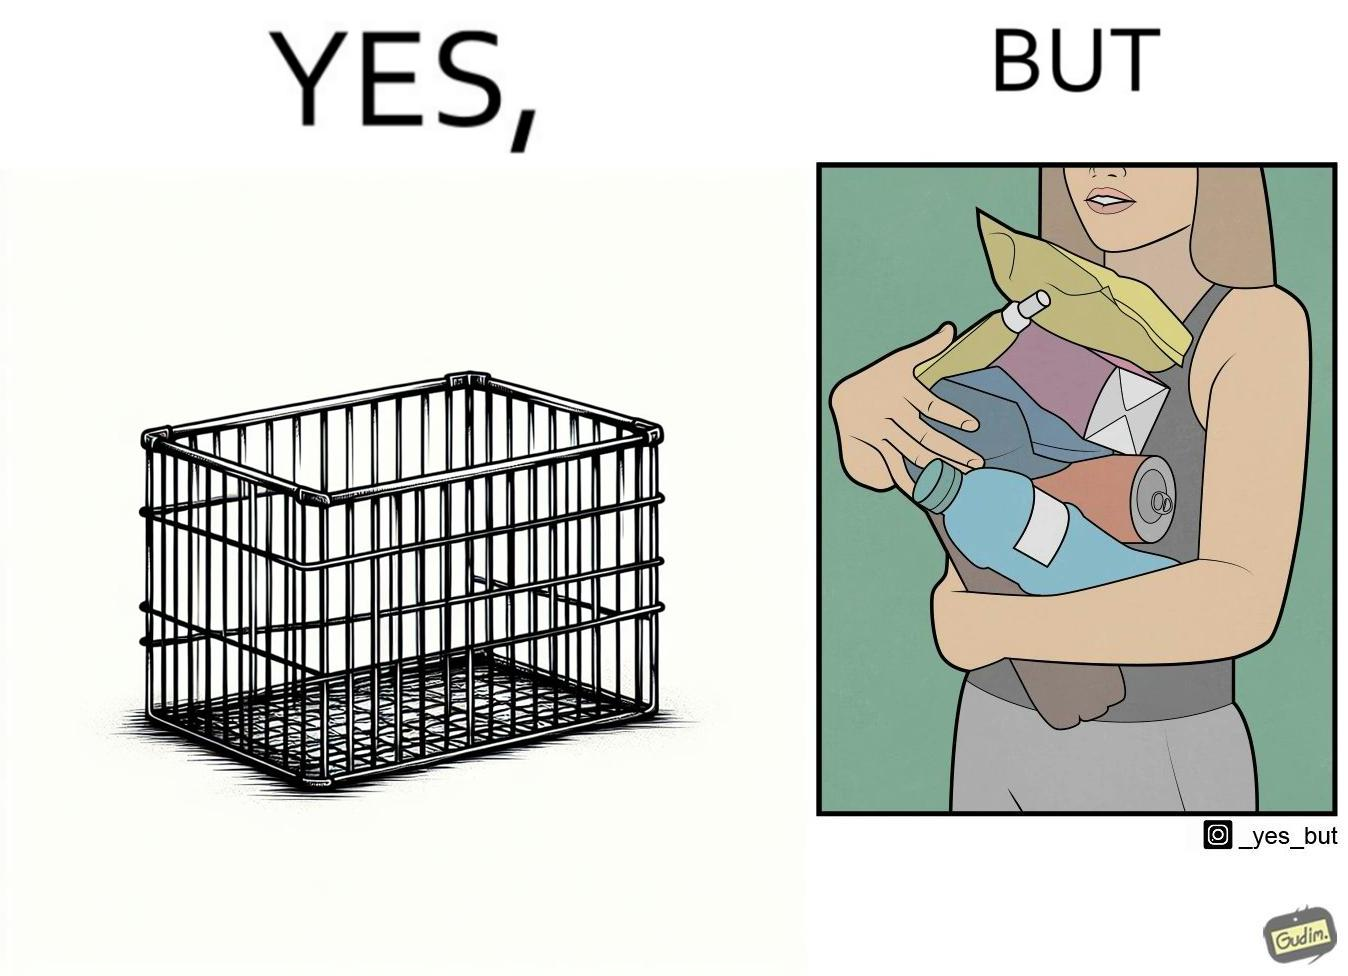What is the satirical meaning behind this image? The image is ironic, because even when there are steel frame baskets are available at the supermarkets people prefer carrying the items in hand 